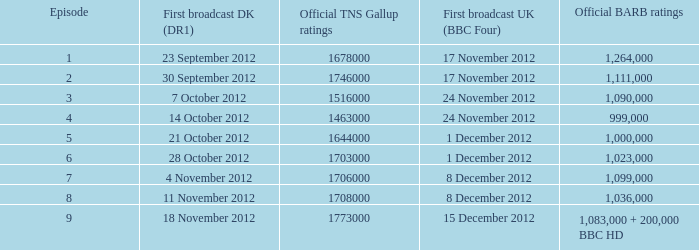What is the BARB ratings of episode 6? 1023000.0. Write the full table. {'header': ['Episode', 'First broadcast DK (DR1)', 'Official TNS Gallup ratings', 'First broadcast UK (BBC Four)', 'Official BARB ratings'], 'rows': [['1', '23 September 2012', '1678000', '17 November 2012', '1,264,000'], ['2', '30 September 2012', '1746000', '17 November 2012', '1,111,000'], ['3', '7 October 2012', '1516000', '24 November 2012', '1,090,000'], ['4', '14 October 2012', '1463000', '24 November 2012', '999,000'], ['5', '21 October 2012', '1644000', '1 December 2012', '1,000,000'], ['6', '28 October 2012', '1703000', '1 December 2012', '1,023,000'], ['7', '4 November 2012', '1706000', '8 December 2012', '1,099,000'], ['8', '11 November 2012', '1708000', '8 December 2012', '1,036,000'], ['9', '18 November 2012', '1773000', '15 December 2012', '1,083,000 + 200,000 BBC HD']]} 